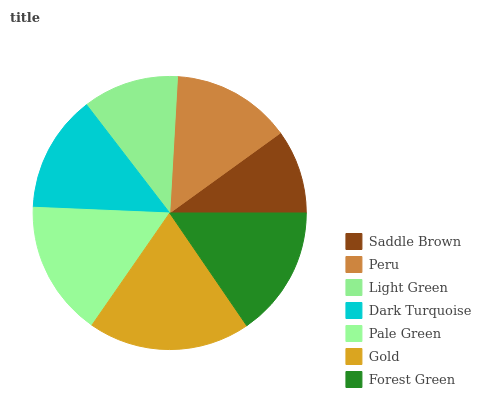Is Saddle Brown the minimum?
Answer yes or no. Yes. Is Gold the maximum?
Answer yes or no. Yes. Is Peru the minimum?
Answer yes or no. No. Is Peru the maximum?
Answer yes or no. No. Is Peru greater than Saddle Brown?
Answer yes or no. Yes. Is Saddle Brown less than Peru?
Answer yes or no. Yes. Is Saddle Brown greater than Peru?
Answer yes or no. No. Is Peru less than Saddle Brown?
Answer yes or no. No. Is Peru the high median?
Answer yes or no. Yes. Is Peru the low median?
Answer yes or no. Yes. Is Gold the high median?
Answer yes or no. No. Is Dark Turquoise the low median?
Answer yes or no. No. 